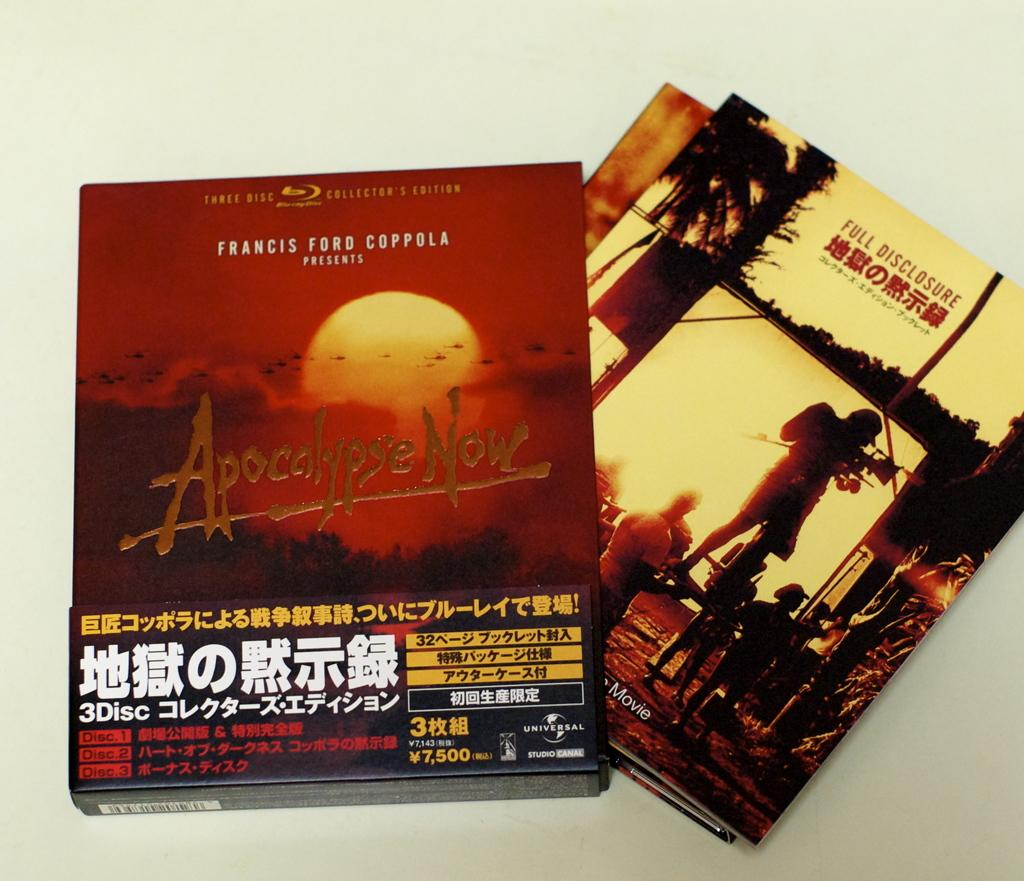<image>
Present a compact description of the photo's key features. Album covers for Apocalypse Now and Full Disclosure. 